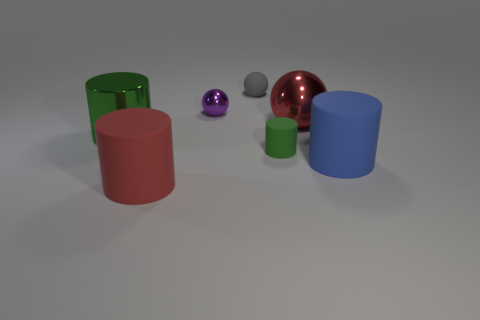Subtract all red cylinders. How many cylinders are left? 3 Subtract all blue matte cylinders. How many cylinders are left? 3 Add 2 red balls. How many objects exist? 9 Subtract all gray cylinders. Subtract all gray spheres. How many cylinders are left? 4 Subtract all spheres. How many objects are left? 4 Add 3 red spheres. How many red spheres are left? 4 Add 1 brown shiny cylinders. How many brown shiny cylinders exist? 1 Subtract 0 cyan cylinders. How many objects are left? 7 Subtract all large blue things. Subtract all tiny balls. How many objects are left? 4 